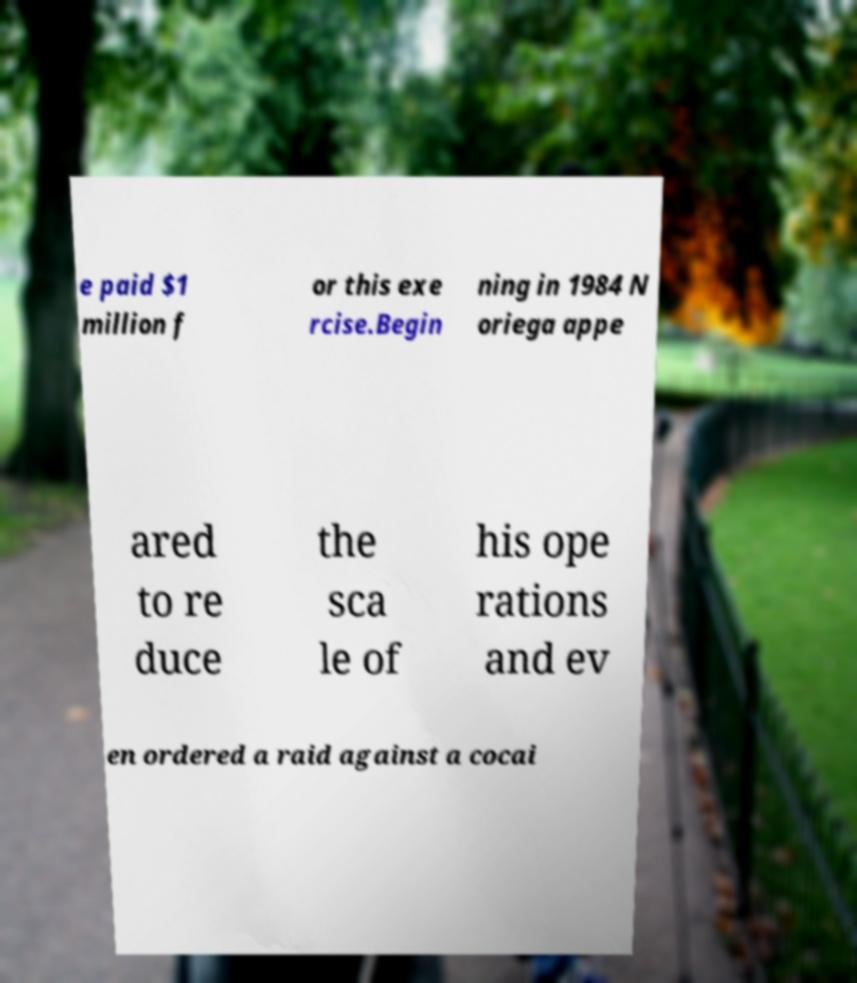For documentation purposes, I need the text within this image transcribed. Could you provide that? e paid $1 million f or this exe rcise.Begin ning in 1984 N oriega appe ared to re duce the sca le of his ope rations and ev en ordered a raid against a cocai 